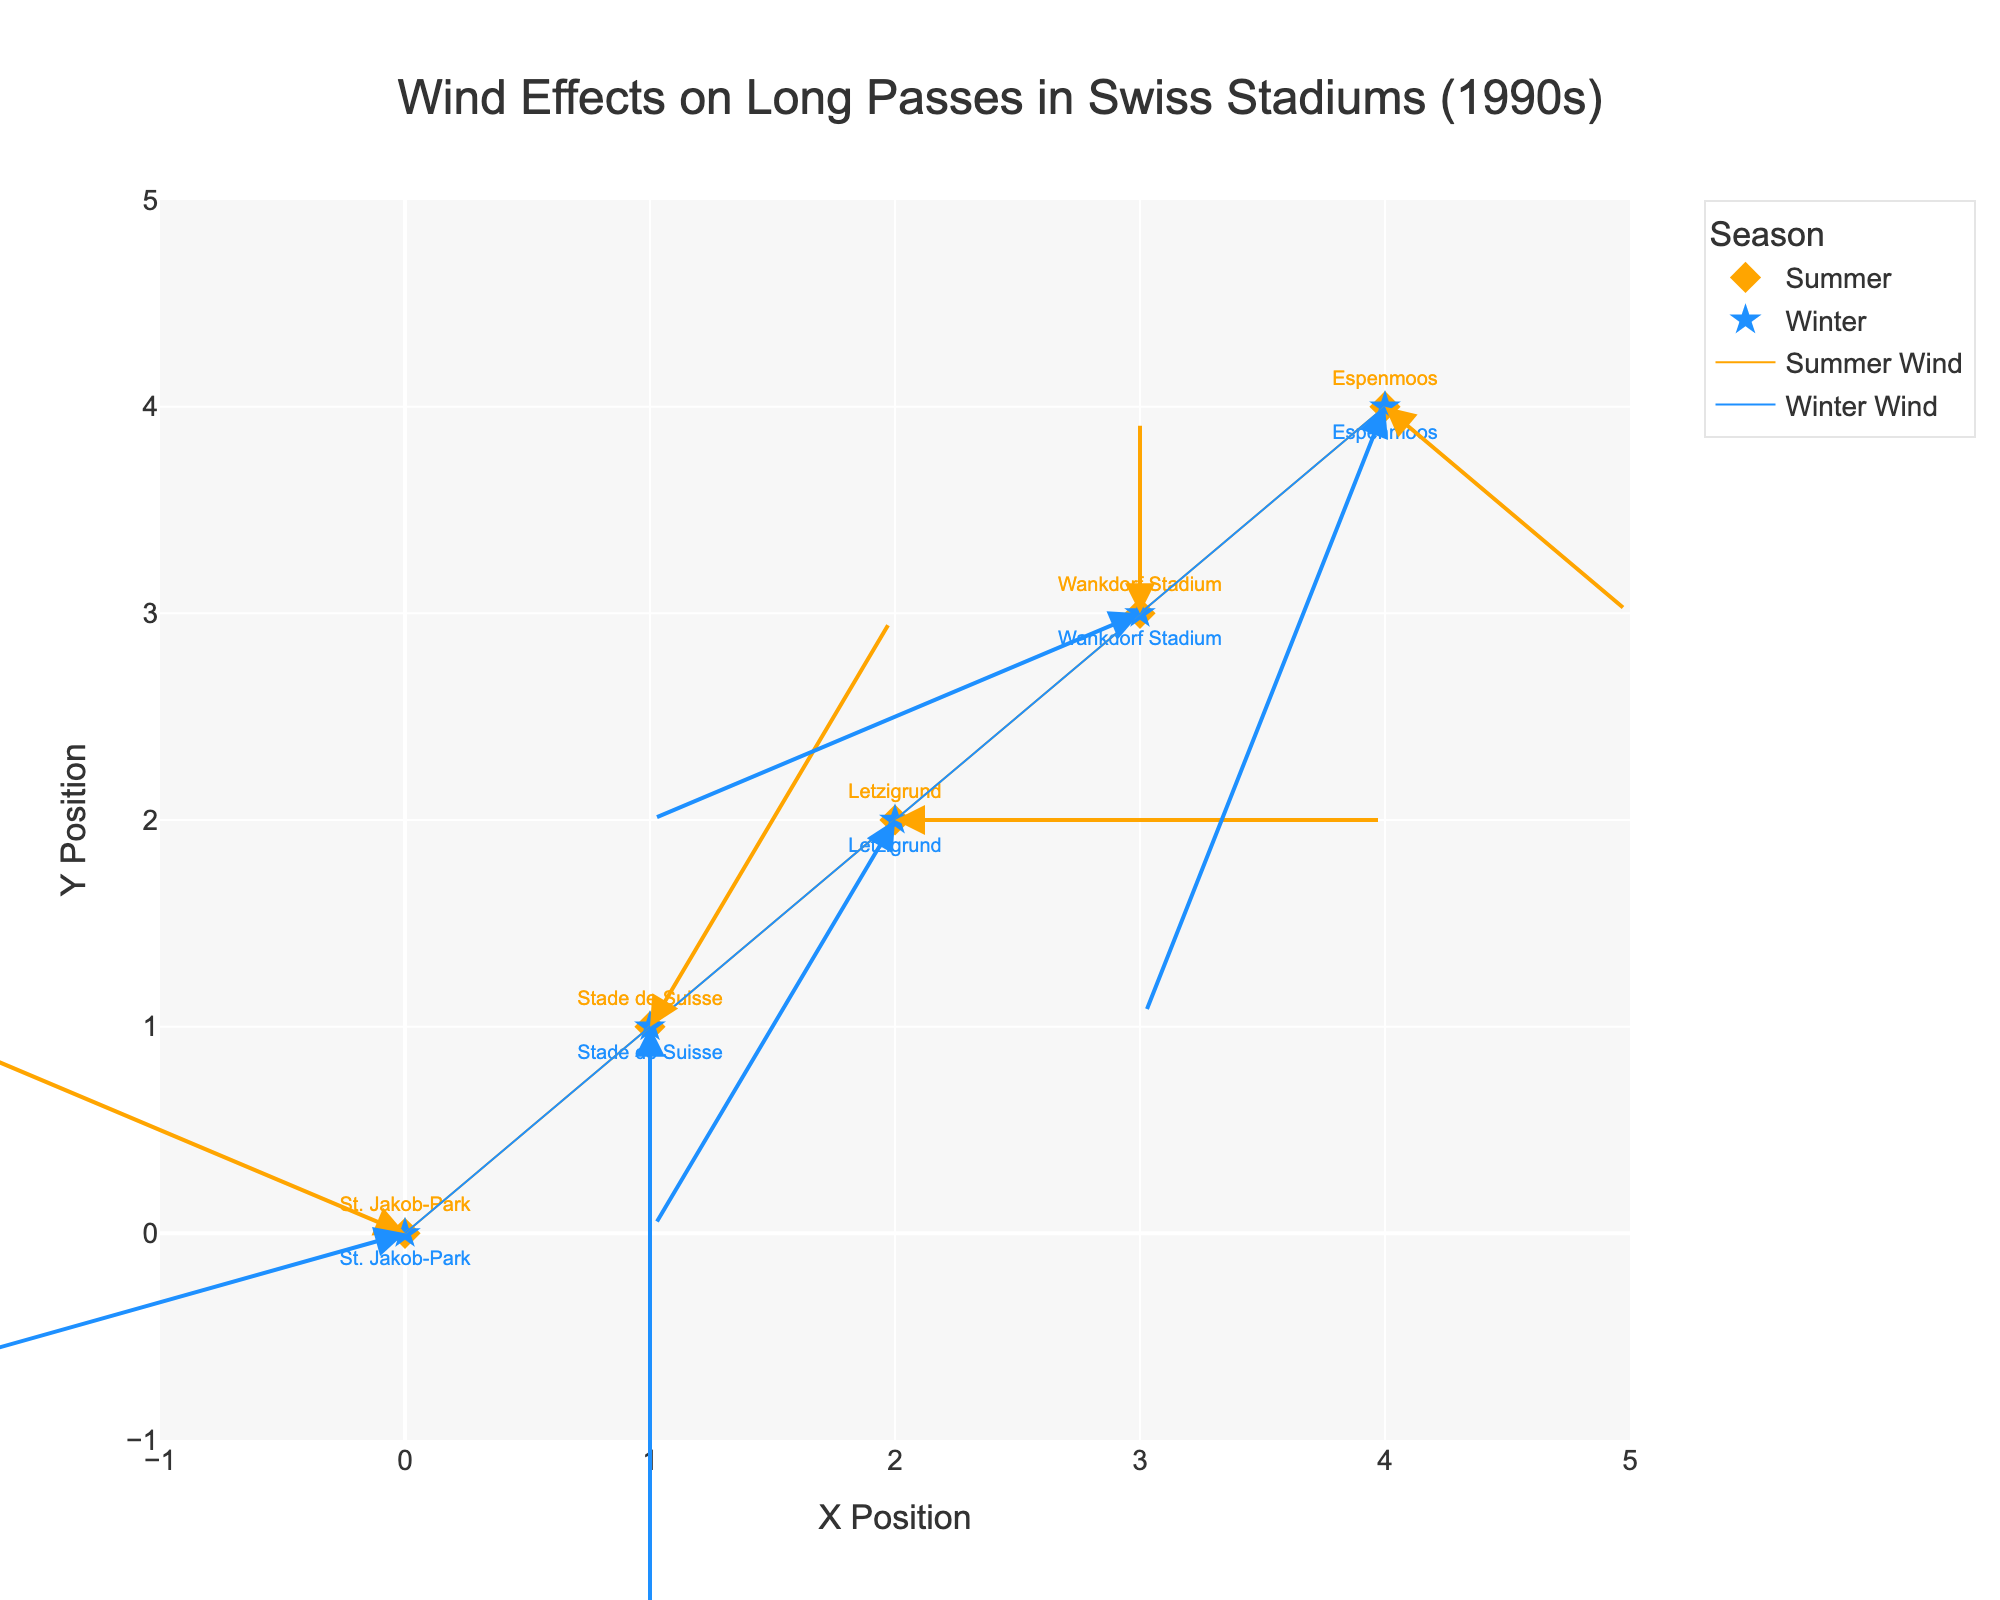What's the title of the figure? The title is usually located at the top of the figure. In this case, it is "Wind Effects on Long Passes in Swiss Stadiums (1990s)."
Answer: Wind Effects on Long Passes in Swiss Stadiums (1990s) Which stadiums are compared in the plot? By looking at the text annotations connected to the markers, the stadiums compared are St. Jakob-Park, Stade de Suisse, Letzigrund, Wankdorf Stadium, and Espenmoos.
Answer: St. Jakob-Park, Stade de Suisse, Letzigrund, Wankdorf Stadium, Espenmoos What colors are used to differentiate between the summer and winter seasons? The figure distinguishes between seasons by color. Summer is represented in orange, while winter is represented in blue.
Answer: Orange (Summer), Blue (Winter) Which stadium shows the largest wind speed in winter? By inspecting the plot, Espenmoos has the longest arrow in winter, indicating the largest wind speed.
Answer: Espenmoos How does the wind direction at Letzigrund differ between summer and winter? For Letzigrund, the summer arrow points to the right (positive U direction), while the winter arrow points downwards-left (negative U and V direction).
Answer: Summer: Right, Winter: Downwards-left What is the average wind speed in winter among all stadiums? Summing the winter wind speeds (7, 6, 5, 6, 8) and averaging them: (7 + 6 + 5 + 6 + 8) / 5 = 32 / 5 = 6.4
Answer: 6.4 Which stadium has the most significant directional change between seasons? Checking the arrows, St. Jakob-Park shows a significant difference as summer points upwards-left, and winter points downwards-left.
Answer: St. Jakob-Park Are there any stadiums where the wind direction remains the same between seasons? By examining the arrows, Stade de Suisse shows a similar direction in both seasons: slightly upwards in summer and downwards in winter.
Answer: No significant direction change How does wind affect the length of passes in the summer compared to the winter? We observe that the arrows in winter generally indicate higher wind speeds than in summer, potentially suggesting longer or more impacted passes.
Answer: Winter has higher wind speeds, which may affect pass length more Which season has more impactful wind at Wankdorf Stadium? At Wankdorf Stadium, the arrow indicating wind speed in winter is longer than the summer one, suggesting more impactful wind in winter.
Answer: Winter 